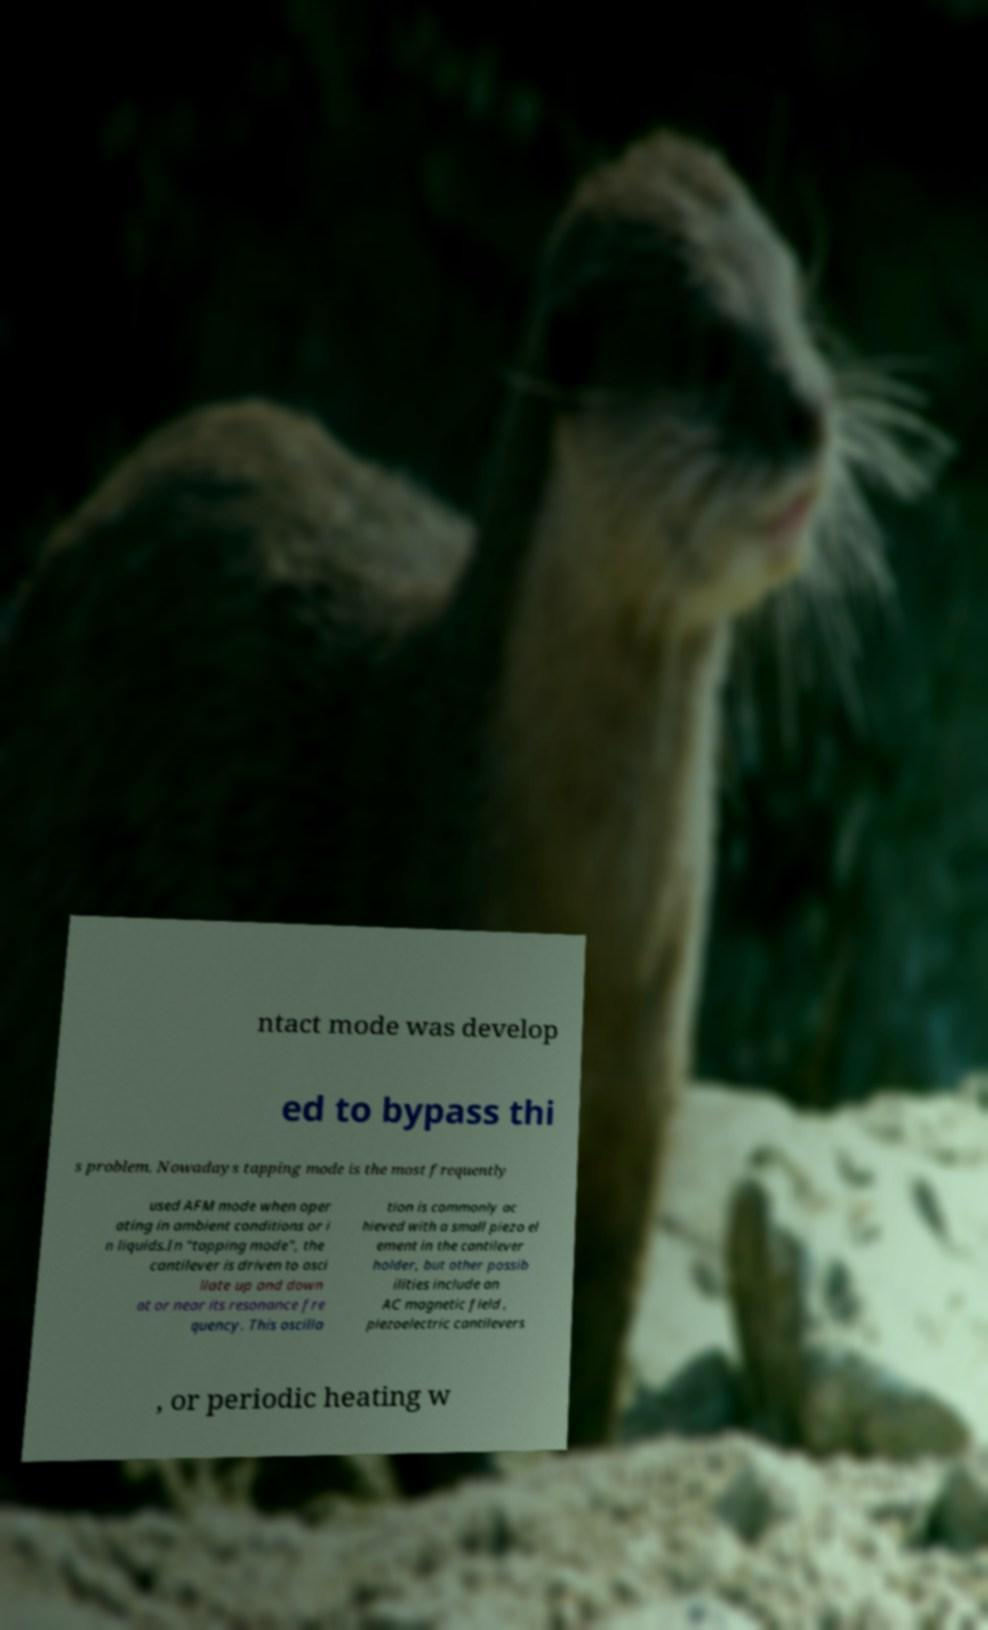Could you extract and type out the text from this image? ntact mode was develop ed to bypass thi s problem. Nowadays tapping mode is the most frequently used AFM mode when oper ating in ambient conditions or i n liquids.In "tapping mode", the cantilever is driven to osci llate up and down at or near its resonance fre quency. This oscilla tion is commonly ac hieved with a small piezo el ement in the cantilever holder, but other possib ilities include an AC magnetic field , piezoelectric cantilevers , or periodic heating w 